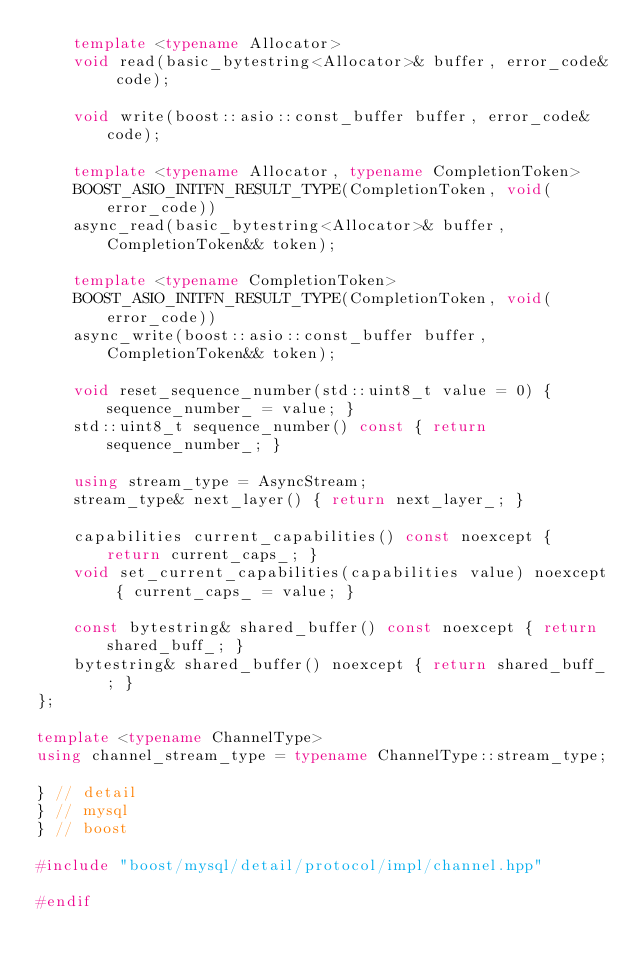<code> <loc_0><loc_0><loc_500><loc_500><_C++_>	template <typename Allocator>
	void read(basic_bytestring<Allocator>& buffer, error_code& code);

	void write(boost::asio::const_buffer buffer, error_code& code);

	template <typename Allocator, typename CompletionToken>
	BOOST_ASIO_INITFN_RESULT_TYPE(CompletionToken, void(error_code))
	async_read(basic_bytestring<Allocator>& buffer, CompletionToken&& token);

	template <typename CompletionToken>
	BOOST_ASIO_INITFN_RESULT_TYPE(CompletionToken, void(error_code))
	async_write(boost::asio::const_buffer buffer, CompletionToken&& token);

	void reset_sequence_number(std::uint8_t value = 0) { sequence_number_ = value; }
	std::uint8_t sequence_number() const { return sequence_number_; }

	using stream_type = AsyncStream;
	stream_type& next_layer() { return next_layer_; }

	capabilities current_capabilities() const noexcept { return current_caps_; }
	void set_current_capabilities(capabilities value) noexcept { current_caps_ = value; }

	const bytestring& shared_buffer() const noexcept { return shared_buff_; }
	bytestring& shared_buffer() noexcept { return shared_buff_; }
};

template <typename ChannelType>
using channel_stream_type = typename ChannelType::stream_type;

} // detail
} // mysql
} // boost

#include "boost/mysql/detail/protocol/impl/channel.hpp"

#endif
</code> 